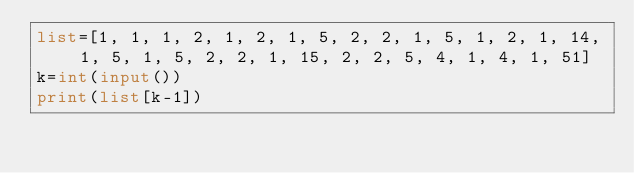<code> <loc_0><loc_0><loc_500><loc_500><_Python_>list=[1, 1, 1, 2, 1, 2, 1, 5, 2, 2, 1, 5, 1, 2, 1, 14, 1, 5, 1, 5, 2, 2, 1, 15, 2, 2, 5, 4, 1, 4, 1, 51]
k=int(input())
print(list[k-1])
</code> 